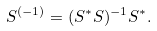<formula> <loc_0><loc_0><loc_500><loc_500>S ^ { ( - 1 ) } = ( S ^ { * } S ) ^ { - 1 } S ^ { * } .</formula> 